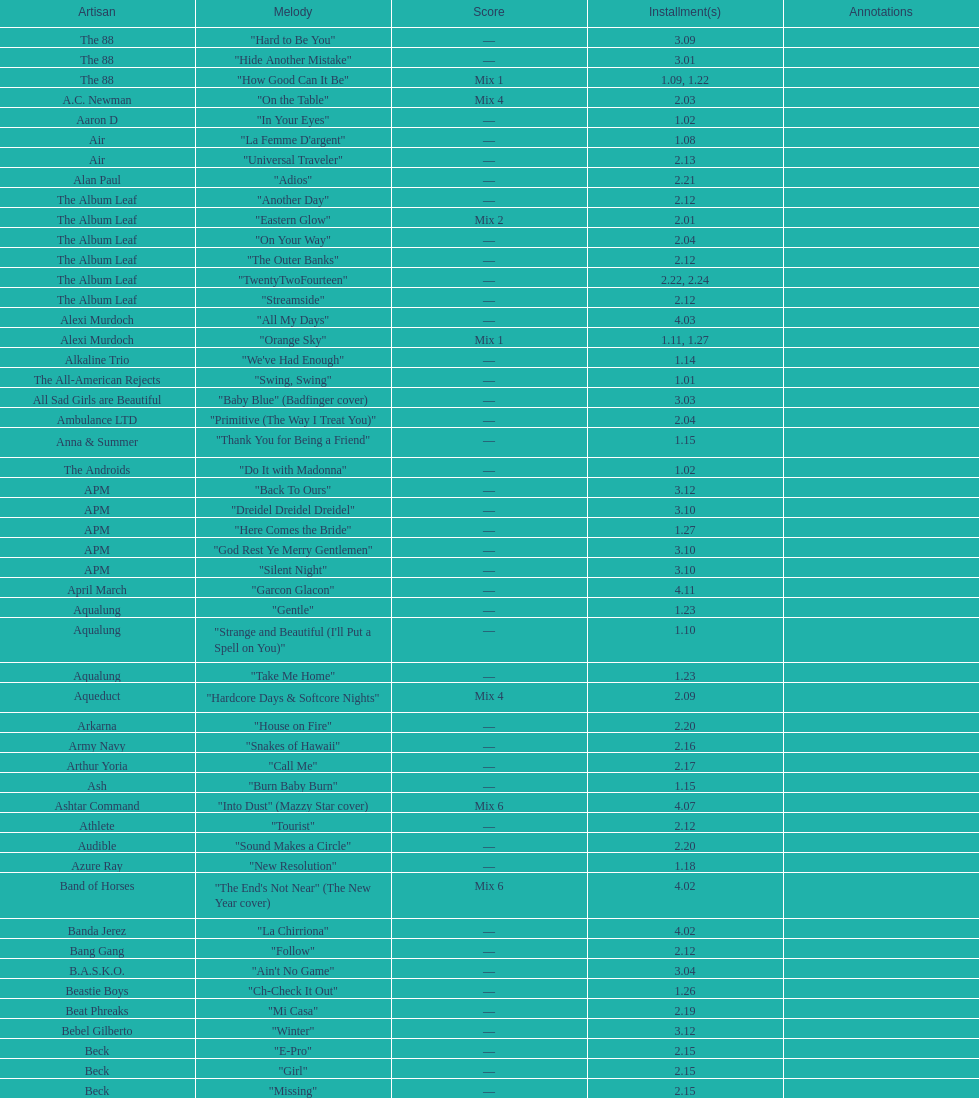"girl" and "el pro" were performed by which artist? Beck. 